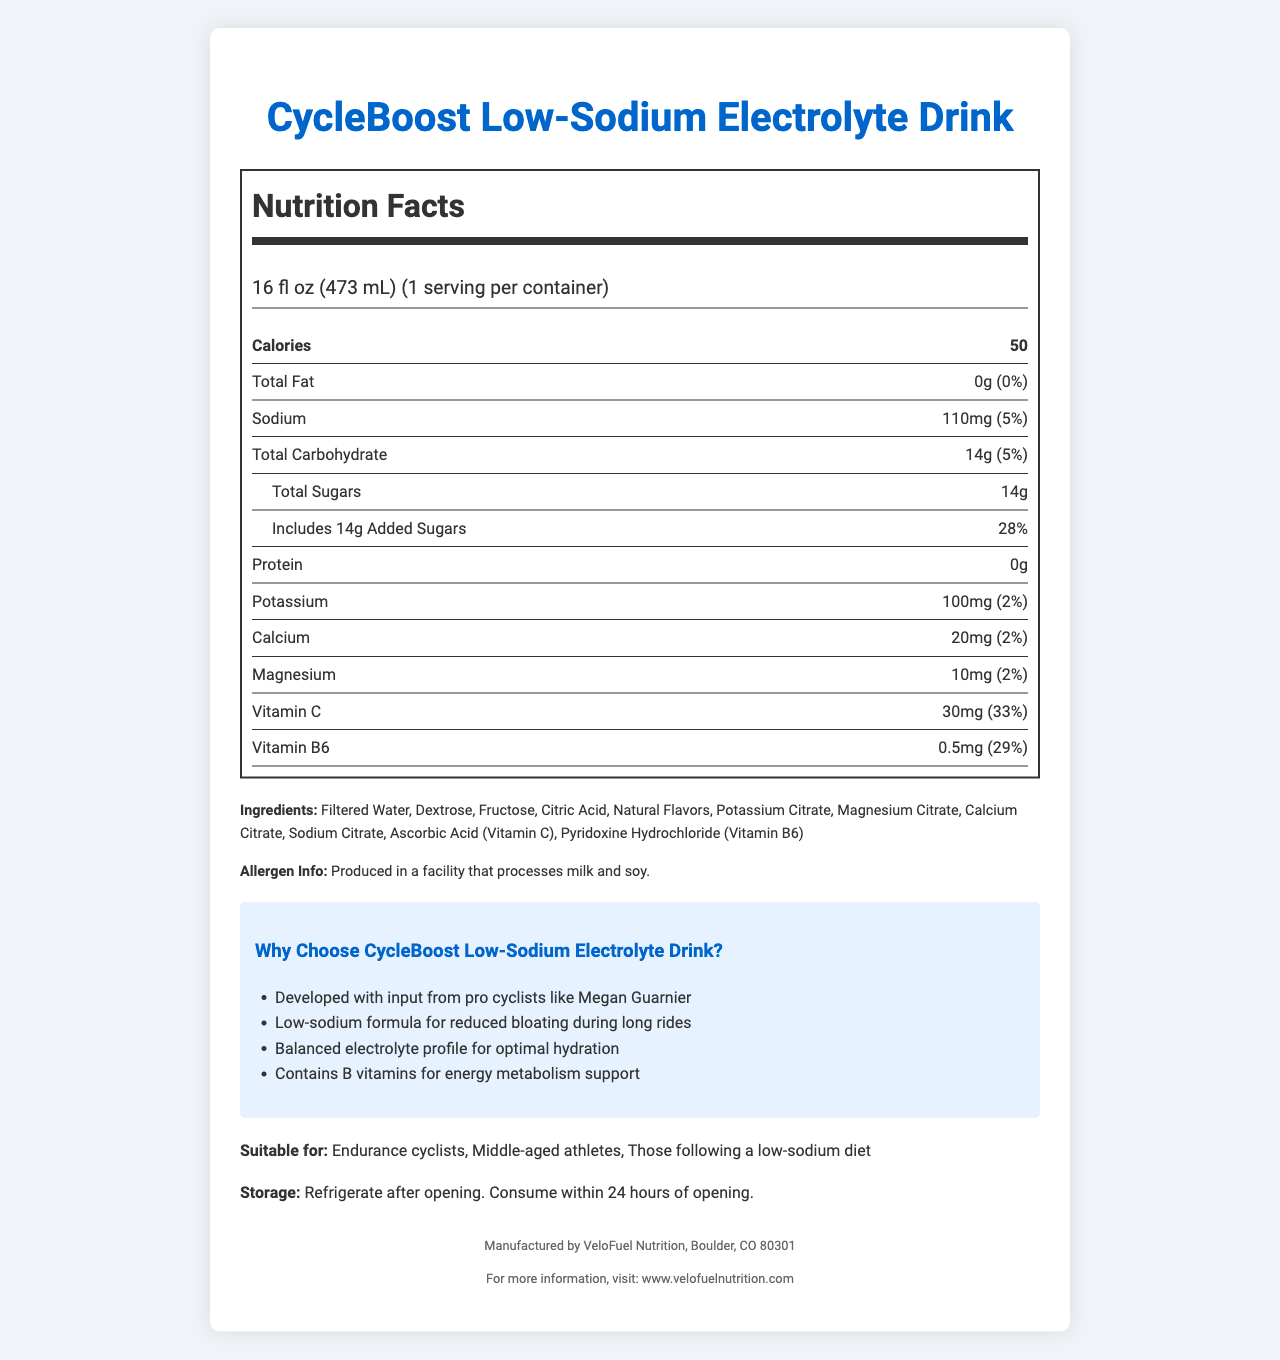what is the serving size of CycleBoost Low-Sodium Electrolyte Drink? The serving size is listed at the top of the nutrition label, stating that one serving equals 16 fluid ounces or 473 milliliters.
Answer: 16 fl oz (473 mL) how many calories are in one serving? The calories per serving are displayed in a bold font and clearly listed as 50.
Answer: 50 how much sodium is in the drink per serving? The sodium content per serving is specified on the nutrition label as 110 milligrams, which also represents 5% of the daily value.
Answer: 110mg what is the percentage of Vitamin C in one serving? The nutrition label lists Vitamin C content as 30mg, which constitutes 33% of the daily value.
Answer: 33% what are the first three ingredients listed? The ingredients are listed in order of predominance, with the first three being Filtered Water, Dextrose, and Fructose.
Answer: Filtered Water, Dextrose, Fructose how many total carbohydrates are in one serving? The total carbohydrate content per serving is listed as 14 grams, which is 5% of the daily value.
Answer: 14g how much added sugar does the drink contain? Under the "Total Sugars" section, it's mentioned that the drink includes 14 grams of added sugars, making up 28% of the daily value.
Answer: 14g how much protein is in one serving? The nutrition facts state that there is 0 grams of protein per serving.
Answer: 0g which marketing claim is NOT made about CycleBoost Low-Sodium Electrolyte Drink? A. Improved mental focus B. Developed with input from pro cyclists C. Low-sodium formula D. Contains B vitamins for energy metabolism support The document does not mention improved mental focus; all other claims are listed under marketing claims.
Answer: A which vitamin has a daily value percentage closest to 30% in one serving? A. Vitamin B6 B. Vitamin C C. Calcium D. Magnesium Vitamin B6 has a daily value percentage of 29%, which is closest to 30%. Vitamin C is 33%, Calcium is 2%, and Magnesium is 2%.
Answer: A is the CycleBoost Low-Sodium Electrolyte Drink suitable for endurance cyclists? The "suitable for" section explicitly mentions that the drink is suitable for endurance cyclists.
Answer: Yes summarize the main features of CycleBoost Low-Sodium Electrolyte Drink. The product is targeted at endurance cyclists and middle-aged athletes, providing essential hydration and energy support while being mindful of sodium intake.
Answer: CycleBoost Low-Sodium Electrolyte Drink is a low-calorie electrolyte beverage designed for cyclists and athletes following a low-sodium diet. It offers balanced electrolytes, contains essential vitamins like Vitamin C and B6, and supports hydration without causing bloating. The drink is made with water, dextrose, and fructose, and excludes fat and protein. It should be refrigerated after opening and consumed within 24 hours. how much potassium does the drink contain? The nutrition label indicates that there are 100 milligrams of potassium per serving, accounting for 2% of the daily value.
Answer: 100mg what is the manufacturer of this drink? The manufacturer information is listed at the bottom of the document, indicating that VeloFuel Nutrition produces this drink.
Answer: VeloFuel Nutrition was Megan Guarnier involved in the development of CycleBoost? One of the marketing claims states that the product was developed with input from professional cyclists like Megan Guarnier.
Answer: Yes how many servings are in each container? The nutrition label mentions that there is one serving per container, implying the entire container equals one serving.
Answer: 1 what is the daily value percentage of added sugars in one serving? The added sugars section shows that the amount in one serving is 14 grams, which is 28% of the daily value.
Answer: 28% what is the specific website for more information about the drink and manufacturer? The manufacturer's website is given at the bottom of the document for additional information.
Answer: www.velofuelnutrition.com is the drink suitable for individuals allergic to milk and soy? While the allergen info mentions the product is produced in a facility that processes milk and soy, it does not confirm whether the drink itself is free from these allergens.
Answer: Not enough information 